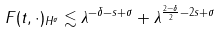<formula> <loc_0><loc_0><loc_500><loc_500>\| F ( t , \cdot ) \| _ { H ^ { \sigma } } \lesssim \lambda ^ { - \delta - s + \sigma } + \lambda ^ { \frac { 2 - \delta } { 2 } - 2 s + \sigma }</formula> 